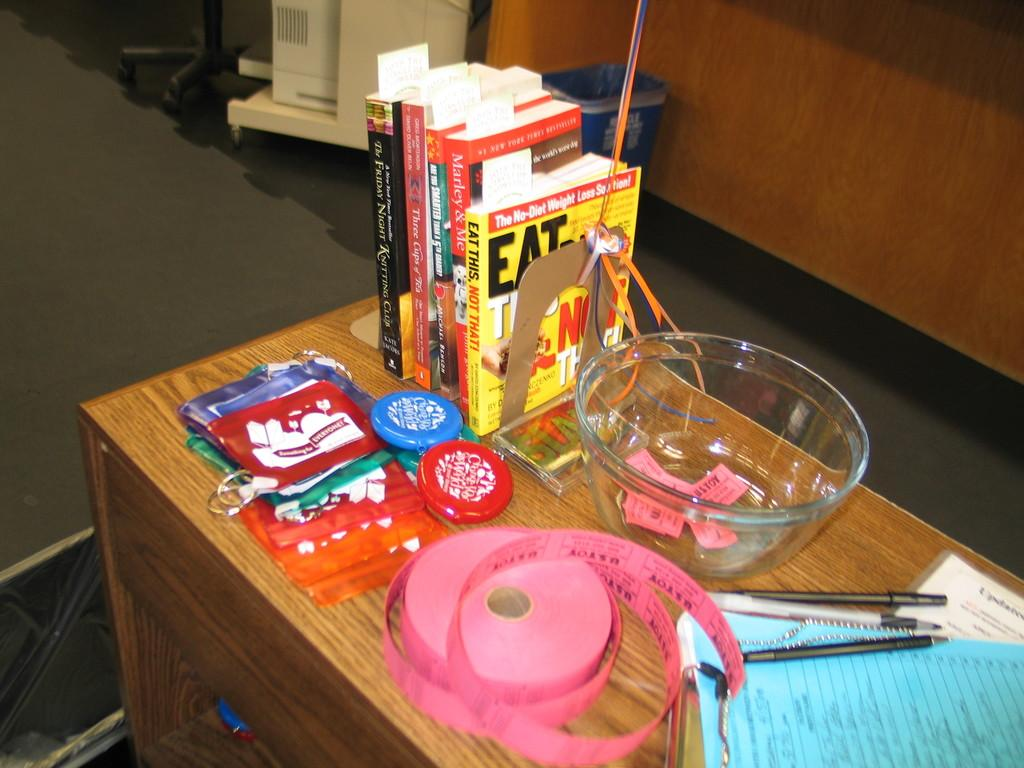<image>
Provide a brief description of the given image. A table with random objects including a copy of the book Eat This, Not That. 